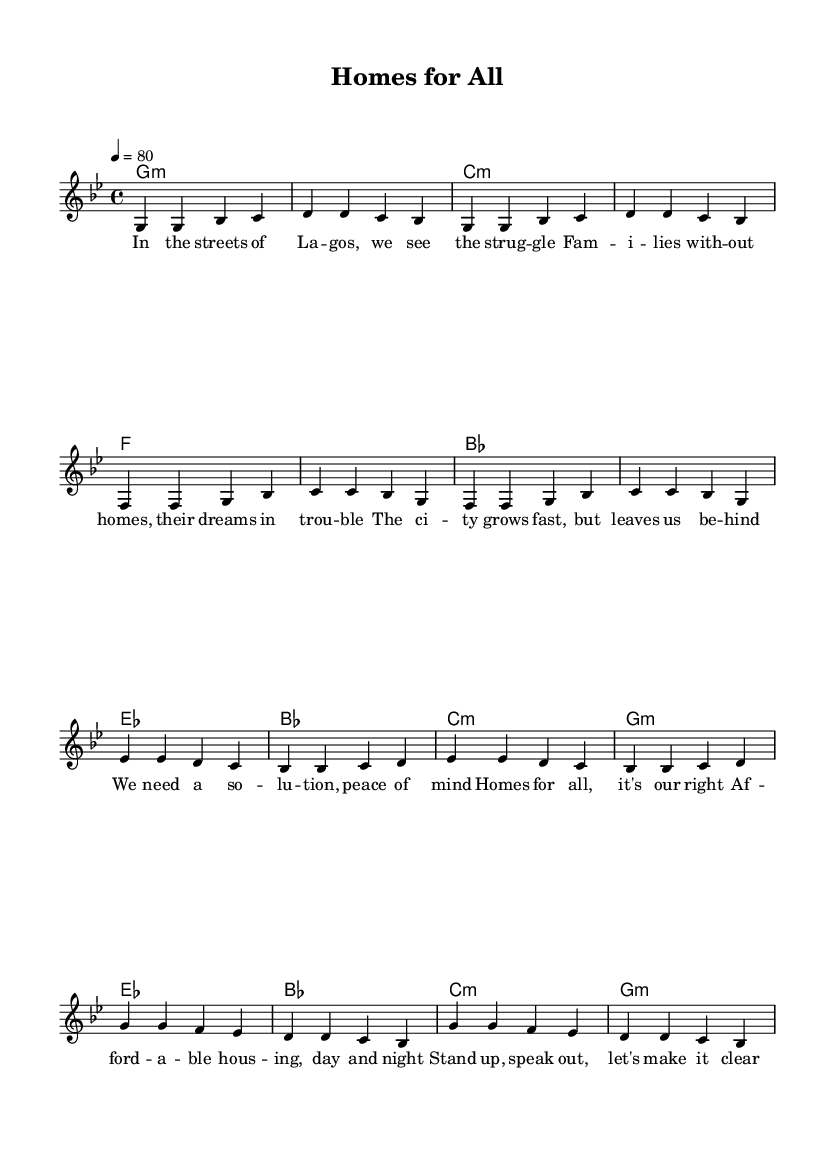What is the key signature of this music? The key signature is G minor, which has two flats (B♭ and E♭). This can be determined from the beginning of the sheet music, where the key signature is indicated.
Answer: G minor What is the time signature of this music? The time signature is 4/4, which means there are four beats in each measure. This is evident from the indication in the beginning of the score, where it specifies "4/4" after the key signature.
Answer: 4/4 What is the tempo of the piece? The tempo is 80 beats per minute. This is marked in the score with the expression "4 = 80," indicating the tempo for the quarter note.
Answer: 80 How many measures are there in the verse? There are 8 measures in the verse. By counting the measures in the section labeled as "Verse," you can determine the total.
Answer: 8 What chord is played in the first measure? The chord in the first measure is G minor. This is indicated in the chord names above the melody and corresponds to the first note of the melody, which is G.
Answer: G minor How does the melody of the chorus differ from the verse? The chorus melody primarily uses higher notes compared to the verse, which utilizes lower notes. Observing the notated pitches in each section shows that the chorus starts on E♭, while the verse starts on G.
Answer: Higher notes What message does the chorus convey regarding housing rights? The chorus conveys a message of advocating for affordable housing as a right. The lyrics clearly express the notion that everyone deserves a home, underscoring the importance of housing rights.
Answer: Advocate for rights 